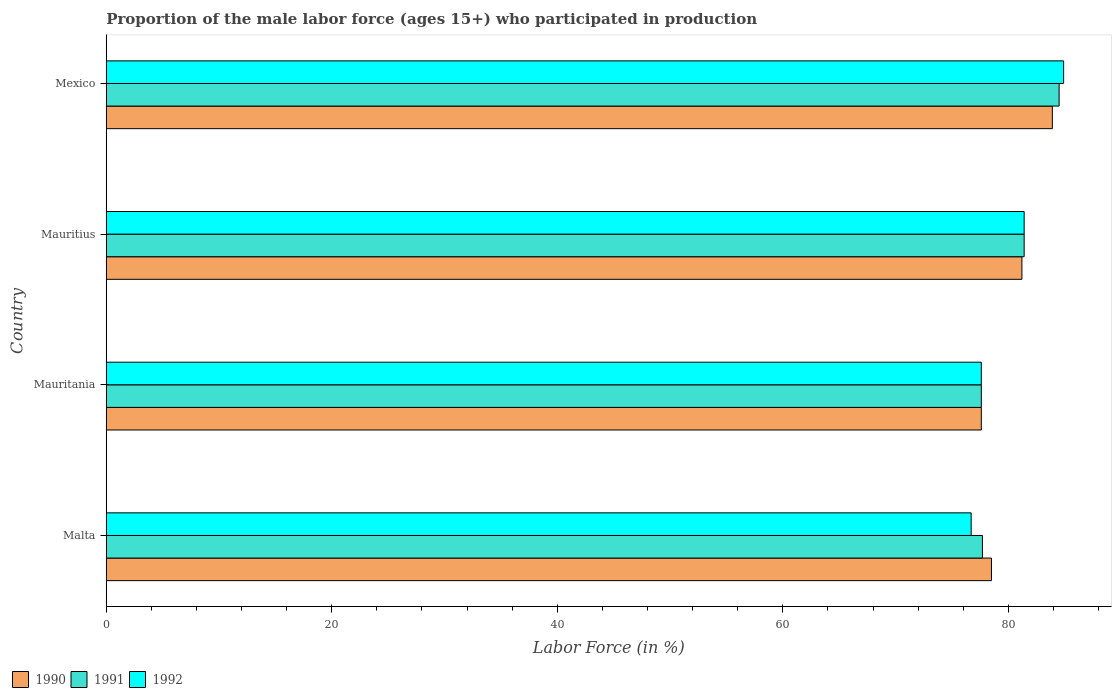How many different coloured bars are there?
Provide a succinct answer. 3. How many groups of bars are there?
Make the answer very short. 4. How many bars are there on the 3rd tick from the top?
Keep it short and to the point. 3. How many bars are there on the 2nd tick from the bottom?
Give a very brief answer. 3. What is the label of the 2nd group of bars from the top?
Your response must be concise. Mauritius. What is the proportion of the male labor force who participated in production in 1991 in Mexico?
Provide a short and direct response. 84.5. Across all countries, what is the maximum proportion of the male labor force who participated in production in 1992?
Ensure brevity in your answer.  84.9. Across all countries, what is the minimum proportion of the male labor force who participated in production in 1990?
Offer a terse response. 77.6. In which country was the proportion of the male labor force who participated in production in 1992 minimum?
Your answer should be compact. Malta. What is the total proportion of the male labor force who participated in production in 1990 in the graph?
Provide a succinct answer. 321.2. What is the difference between the proportion of the male labor force who participated in production in 1990 in Malta and that in Mexico?
Ensure brevity in your answer.  -5.4. What is the difference between the proportion of the male labor force who participated in production in 1991 in Mauritania and the proportion of the male labor force who participated in production in 1990 in Mexico?
Your response must be concise. -6.3. What is the average proportion of the male labor force who participated in production in 1992 per country?
Your response must be concise. 80.15. In how many countries, is the proportion of the male labor force who participated in production in 1992 greater than 76 %?
Your answer should be very brief. 4. What is the ratio of the proportion of the male labor force who participated in production in 1991 in Mauritania to that in Mexico?
Give a very brief answer. 0.92. Is the proportion of the male labor force who participated in production in 1990 in Mauritania less than that in Mauritius?
Offer a terse response. Yes. Is the difference between the proportion of the male labor force who participated in production in 1992 in Malta and Mauritius greater than the difference between the proportion of the male labor force who participated in production in 1990 in Malta and Mauritius?
Make the answer very short. No. What is the difference between the highest and the second highest proportion of the male labor force who participated in production in 1990?
Ensure brevity in your answer.  2.7. What is the difference between the highest and the lowest proportion of the male labor force who participated in production in 1990?
Offer a terse response. 6.3. What does the 2nd bar from the bottom in Malta represents?
Offer a very short reply. 1991. How many bars are there?
Ensure brevity in your answer.  12. How many legend labels are there?
Provide a succinct answer. 3. How are the legend labels stacked?
Ensure brevity in your answer.  Horizontal. What is the title of the graph?
Your answer should be compact. Proportion of the male labor force (ages 15+) who participated in production. What is the Labor Force (in %) of 1990 in Malta?
Ensure brevity in your answer.  78.5. What is the Labor Force (in %) in 1991 in Malta?
Your response must be concise. 77.7. What is the Labor Force (in %) of 1992 in Malta?
Offer a terse response. 76.7. What is the Labor Force (in %) in 1990 in Mauritania?
Ensure brevity in your answer.  77.6. What is the Labor Force (in %) of 1991 in Mauritania?
Your answer should be very brief. 77.6. What is the Labor Force (in %) in 1992 in Mauritania?
Offer a terse response. 77.6. What is the Labor Force (in %) in 1990 in Mauritius?
Your answer should be very brief. 81.2. What is the Labor Force (in %) of 1991 in Mauritius?
Your response must be concise. 81.4. What is the Labor Force (in %) in 1992 in Mauritius?
Ensure brevity in your answer.  81.4. What is the Labor Force (in %) of 1990 in Mexico?
Give a very brief answer. 83.9. What is the Labor Force (in %) in 1991 in Mexico?
Provide a short and direct response. 84.5. What is the Labor Force (in %) in 1992 in Mexico?
Give a very brief answer. 84.9. Across all countries, what is the maximum Labor Force (in %) of 1990?
Keep it short and to the point. 83.9. Across all countries, what is the maximum Labor Force (in %) of 1991?
Provide a succinct answer. 84.5. Across all countries, what is the maximum Labor Force (in %) of 1992?
Ensure brevity in your answer.  84.9. Across all countries, what is the minimum Labor Force (in %) in 1990?
Your answer should be very brief. 77.6. Across all countries, what is the minimum Labor Force (in %) of 1991?
Make the answer very short. 77.6. Across all countries, what is the minimum Labor Force (in %) in 1992?
Give a very brief answer. 76.7. What is the total Labor Force (in %) in 1990 in the graph?
Offer a terse response. 321.2. What is the total Labor Force (in %) of 1991 in the graph?
Your answer should be compact. 321.2. What is the total Labor Force (in %) of 1992 in the graph?
Offer a very short reply. 320.6. What is the difference between the Labor Force (in %) in 1990 in Malta and that in Mauritania?
Give a very brief answer. 0.9. What is the difference between the Labor Force (in %) of 1991 in Malta and that in Mauritania?
Your answer should be very brief. 0.1. What is the difference between the Labor Force (in %) of 1990 in Malta and that in Mauritius?
Keep it short and to the point. -2.7. What is the difference between the Labor Force (in %) in 1990 in Mauritania and that in Mauritius?
Keep it short and to the point. -3.6. What is the difference between the Labor Force (in %) in 1991 in Mauritania and that in Mexico?
Your response must be concise. -6.9. What is the difference between the Labor Force (in %) of 1991 in Mauritius and that in Mexico?
Provide a succinct answer. -3.1. What is the difference between the Labor Force (in %) of 1992 in Mauritius and that in Mexico?
Provide a succinct answer. -3.5. What is the difference between the Labor Force (in %) in 1990 in Malta and the Labor Force (in %) in 1991 in Mauritius?
Your answer should be very brief. -2.9. What is the difference between the Labor Force (in %) in 1990 in Malta and the Labor Force (in %) in 1992 in Mauritius?
Offer a very short reply. -2.9. What is the difference between the Labor Force (in %) of 1991 in Malta and the Labor Force (in %) of 1992 in Mauritius?
Offer a very short reply. -3.7. What is the difference between the Labor Force (in %) of 1990 in Malta and the Labor Force (in %) of 1991 in Mexico?
Provide a succinct answer. -6. What is the difference between the Labor Force (in %) of 1990 in Malta and the Labor Force (in %) of 1992 in Mexico?
Offer a terse response. -6.4. What is the difference between the Labor Force (in %) in 1991 in Malta and the Labor Force (in %) in 1992 in Mexico?
Provide a succinct answer. -7.2. What is the difference between the Labor Force (in %) of 1990 in Mauritania and the Labor Force (in %) of 1992 in Mauritius?
Provide a short and direct response. -3.8. What is the difference between the Labor Force (in %) of 1991 in Mauritania and the Labor Force (in %) of 1992 in Mauritius?
Make the answer very short. -3.8. What is the difference between the Labor Force (in %) in 1991 in Mauritania and the Labor Force (in %) in 1992 in Mexico?
Offer a terse response. -7.3. What is the difference between the Labor Force (in %) of 1990 in Mauritius and the Labor Force (in %) of 1991 in Mexico?
Ensure brevity in your answer.  -3.3. What is the average Labor Force (in %) of 1990 per country?
Your answer should be compact. 80.3. What is the average Labor Force (in %) in 1991 per country?
Offer a very short reply. 80.3. What is the average Labor Force (in %) in 1992 per country?
Your answer should be very brief. 80.15. What is the difference between the Labor Force (in %) in 1990 and Labor Force (in %) in 1991 in Malta?
Ensure brevity in your answer.  0.8. What is the difference between the Labor Force (in %) of 1990 and Labor Force (in %) of 1992 in Mauritania?
Your answer should be compact. 0. What is the difference between the Labor Force (in %) of 1990 and Labor Force (in %) of 1991 in Mauritius?
Your answer should be compact. -0.2. What is the difference between the Labor Force (in %) of 1990 and Labor Force (in %) of 1992 in Mauritius?
Ensure brevity in your answer.  -0.2. What is the difference between the Labor Force (in %) of 1991 and Labor Force (in %) of 1992 in Mauritius?
Your response must be concise. 0. What is the difference between the Labor Force (in %) of 1990 and Labor Force (in %) of 1991 in Mexico?
Provide a short and direct response. -0.6. What is the difference between the Labor Force (in %) of 1991 and Labor Force (in %) of 1992 in Mexico?
Keep it short and to the point. -0.4. What is the ratio of the Labor Force (in %) in 1990 in Malta to that in Mauritania?
Provide a succinct answer. 1.01. What is the ratio of the Labor Force (in %) of 1991 in Malta to that in Mauritania?
Your response must be concise. 1. What is the ratio of the Labor Force (in %) in 1992 in Malta to that in Mauritania?
Offer a very short reply. 0.99. What is the ratio of the Labor Force (in %) of 1990 in Malta to that in Mauritius?
Your answer should be compact. 0.97. What is the ratio of the Labor Force (in %) of 1991 in Malta to that in Mauritius?
Your answer should be compact. 0.95. What is the ratio of the Labor Force (in %) in 1992 in Malta to that in Mauritius?
Give a very brief answer. 0.94. What is the ratio of the Labor Force (in %) in 1990 in Malta to that in Mexico?
Keep it short and to the point. 0.94. What is the ratio of the Labor Force (in %) of 1991 in Malta to that in Mexico?
Your answer should be compact. 0.92. What is the ratio of the Labor Force (in %) of 1992 in Malta to that in Mexico?
Your answer should be very brief. 0.9. What is the ratio of the Labor Force (in %) of 1990 in Mauritania to that in Mauritius?
Make the answer very short. 0.96. What is the ratio of the Labor Force (in %) of 1991 in Mauritania to that in Mauritius?
Your answer should be very brief. 0.95. What is the ratio of the Labor Force (in %) in 1992 in Mauritania to that in Mauritius?
Your answer should be compact. 0.95. What is the ratio of the Labor Force (in %) in 1990 in Mauritania to that in Mexico?
Your answer should be very brief. 0.92. What is the ratio of the Labor Force (in %) of 1991 in Mauritania to that in Mexico?
Your response must be concise. 0.92. What is the ratio of the Labor Force (in %) of 1992 in Mauritania to that in Mexico?
Provide a succinct answer. 0.91. What is the ratio of the Labor Force (in %) in 1990 in Mauritius to that in Mexico?
Ensure brevity in your answer.  0.97. What is the ratio of the Labor Force (in %) of 1991 in Mauritius to that in Mexico?
Offer a terse response. 0.96. What is the ratio of the Labor Force (in %) in 1992 in Mauritius to that in Mexico?
Your answer should be very brief. 0.96. What is the difference between the highest and the second highest Labor Force (in %) in 1991?
Your answer should be compact. 3.1. What is the difference between the highest and the second highest Labor Force (in %) of 1992?
Offer a very short reply. 3.5. What is the difference between the highest and the lowest Labor Force (in %) of 1991?
Give a very brief answer. 6.9. 